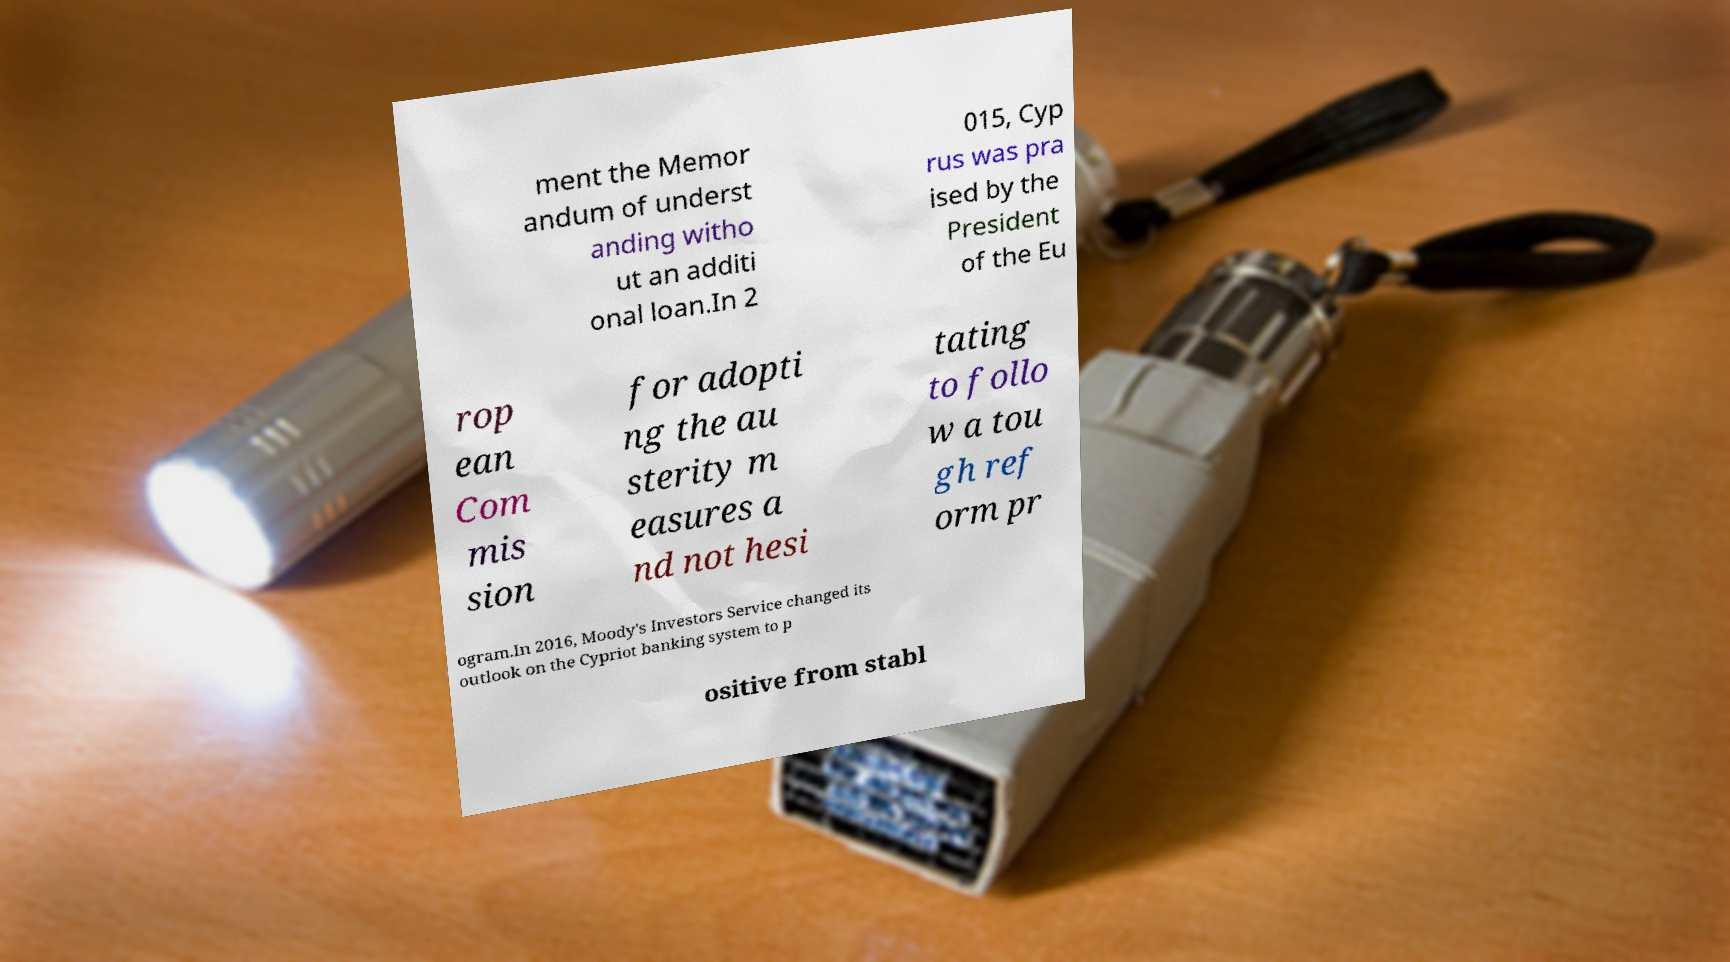Can you accurately transcribe the text from the provided image for me? ment the Memor andum of underst anding witho ut an additi onal loan.In 2 015, Cyp rus was pra ised by the President of the Eu rop ean Com mis sion for adopti ng the au sterity m easures a nd not hesi tating to follo w a tou gh ref orm pr ogram.In 2016, Moody's Investors Service changed its outlook on the Cypriot banking system to p ositive from stabl 